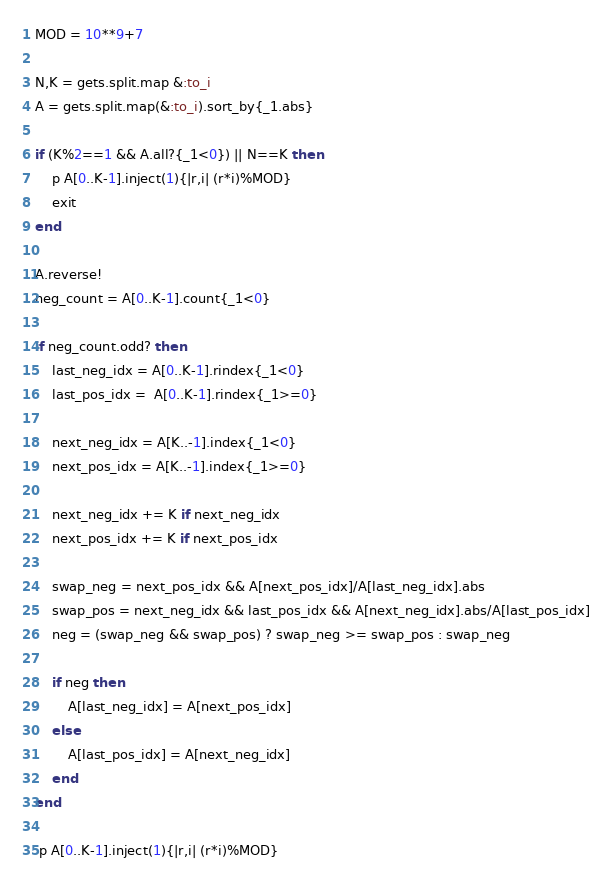<code> <loc_0><loc_0><loc_500><loc_500><_Ruby_>MOD = 10**9+7

N,K = gets.split.map &:to_i
A = gets.split.map(&:to_i).sort_by{_1.abs}

if (K%2==1 && A.all?{_1<0}) || N==K then
    p A[0..K-1].inject(1){|r,i| (r*i)%MOD}
    exit
end

A.reverse!
neg_count = A[0..K-1].count{_1<0}

if neg_count.odd? then
    last_neg_idx = A[0..K-1].rindex{_1<0}
    last_pos_idx =  A[0..K-1].rindex{_1>=0}

    next_neg_idx = A[K..-1].index{_1<0}
    next_pos_idx = A[K..-1].index{_1>=0}

    next_neg_idx += K if next_neg_idx
    next_pos_idx += K if next_pos_idx

    swap_neg = next_pos_idx && A[next_pos_idx]/A[last_neg_idx].abs
    swap_pos = next_neg_idx && last_pos_idx && A[next_neg_idx].abs/A[last_pos_idx]
    neg = (swap_neg && swap_pos) ? swap_neg >= swap_pos : swap_neg

    if neg then
        A[last_neg_idx] = A[next_pos_idx]
    else
        A[last_pos_idx] = A[next_neg_idx]
    end
end

 p A[0..K-1].inject(1){|r,i| (r*i)%MOD}</code> 